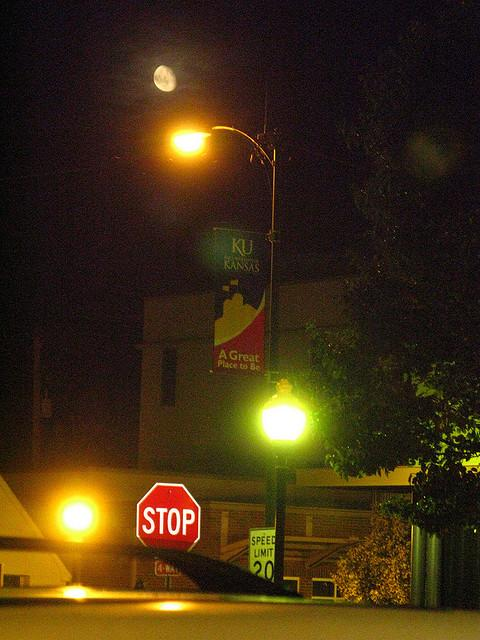How many lights are shining bright on the side of the campus street? three 